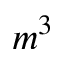Convert formula to latex. <formula><loc_0><loc_0><loc_500><loc_500>m ^ { 3 }</formula> 